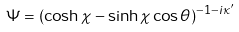Convert formula to latex. <formula><loc_0><loc_0><loc_500><loc_500>\Psi = ( \cosh \chi - \sinh \chi \cos \theta ) ^ { - 1 - i \kappa ^ { \prime } }</formula> 